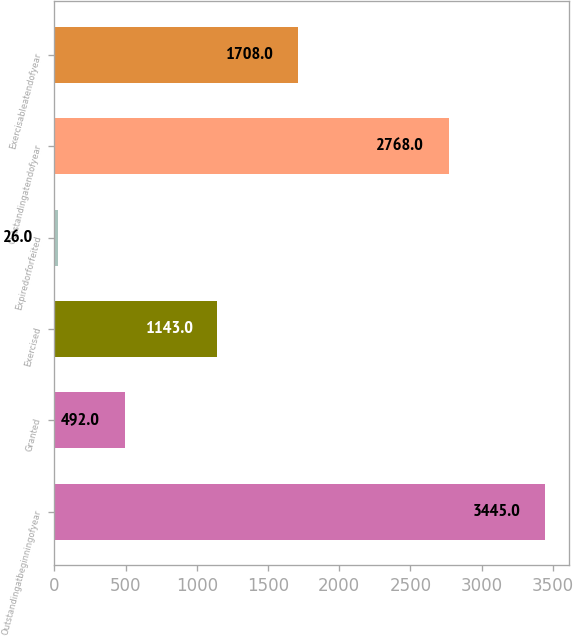<chart> <loc_0><loc_0><loc_500><loc_500><bar_chart><fcel>Outstandingatbeginningofyear<fcel>Granted<fcel>Exercised<fcel>Expiredorforfeited<fcel>Outstandingatendofyear<fcel>Exercisableatendofyear<nl><fcel>3445<fcel>492<fcel>1143<fcel>26<fcel>2768<fcel>1708<nl></chart> 